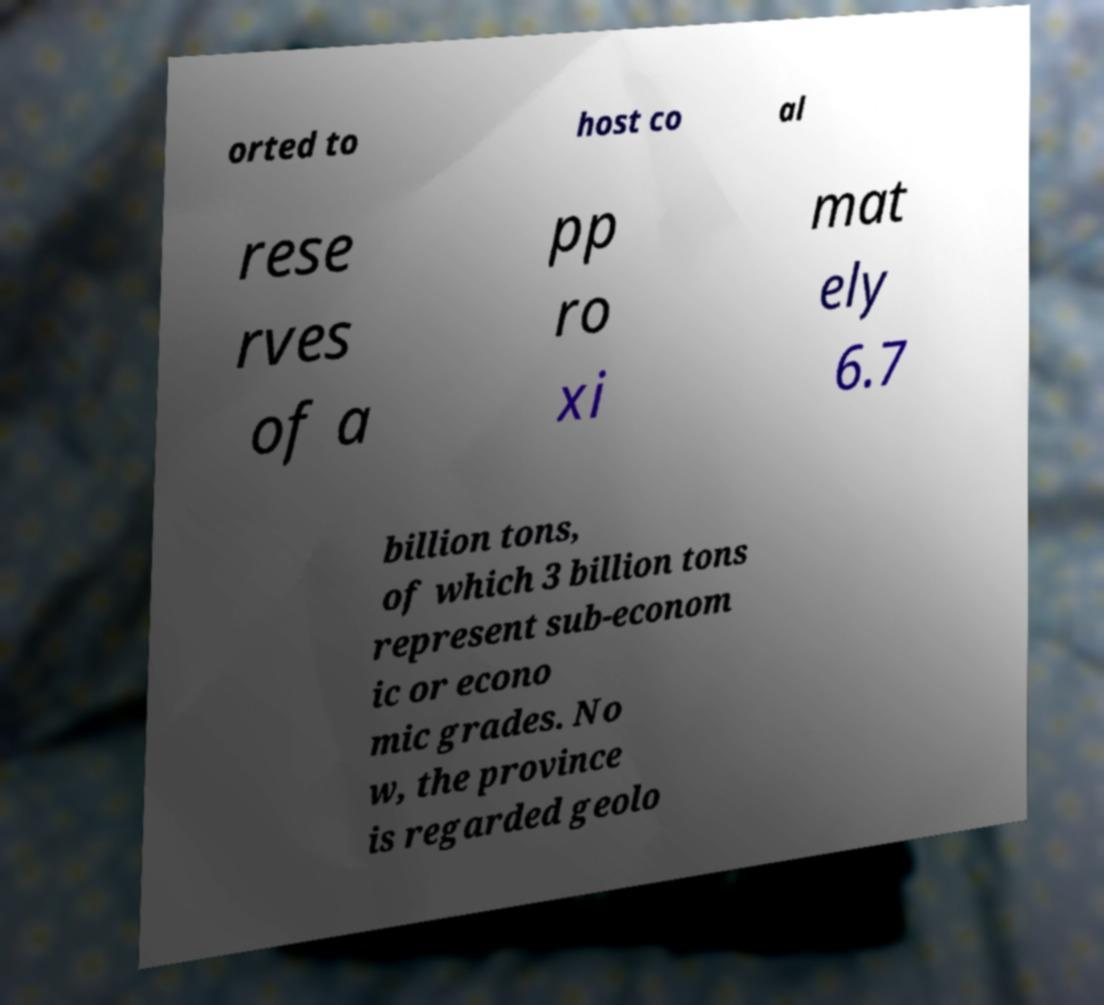Could you assist in decoding the text presented in this image and type it out clearly? orted to host co al rese rves of a pp ro xi mat ely 6.7 billion tons, of which 3 billion tons represent sub-econom ic or econo mic grades. No w, the province is regarded geolo 